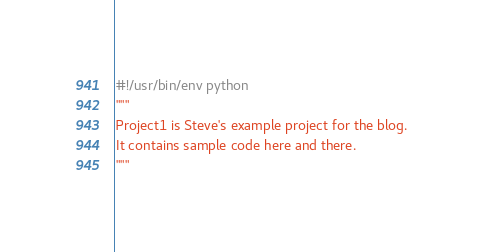<code> <loc_0><loc_0><loc_500><loc_500><_Python_>#!/usr/bin/env python
"""
Project1 is Steve's example project for the blog.
It contains sample code here and there.
"""

</code> 